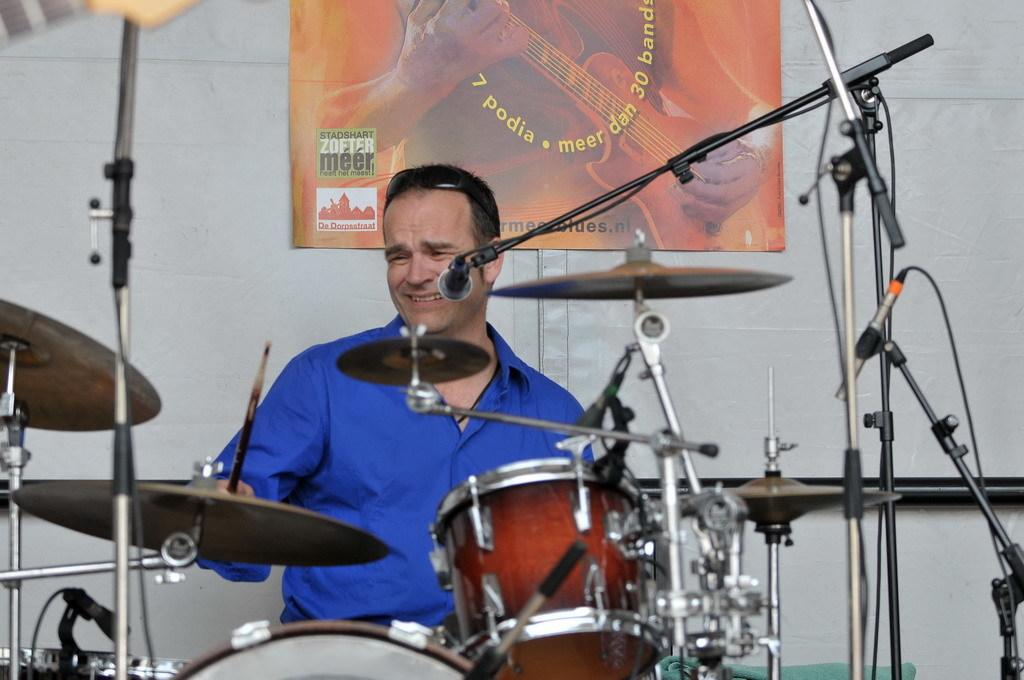What is the main subject of the image? There is a person in the image. What is the person wearing? The person is wearing a blue shirt. What activity is the person engaged in? The person is playing drums. What object is in front of the person? The person is standing in front of a microphone. Can you see any tigers or plantations in the image? No, there are no tigers or plantations present in the image. 